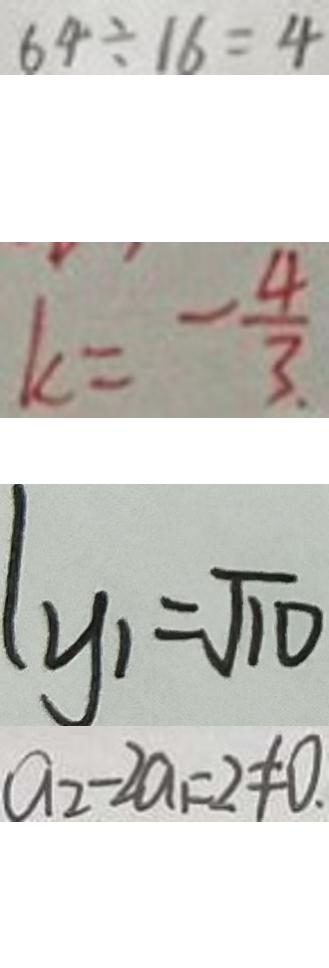<formula> <loc_0><loc_0><loc_500><loc_500>6 4 \div 1 6 = 4 
 k = - \frac { 4 } { 3 } 
 y _ { 1 } = \sqrt { 1 0 } 
 a _ { 2 } - 2 a _ { 1 } = 2 \neq 0 .</formula> 